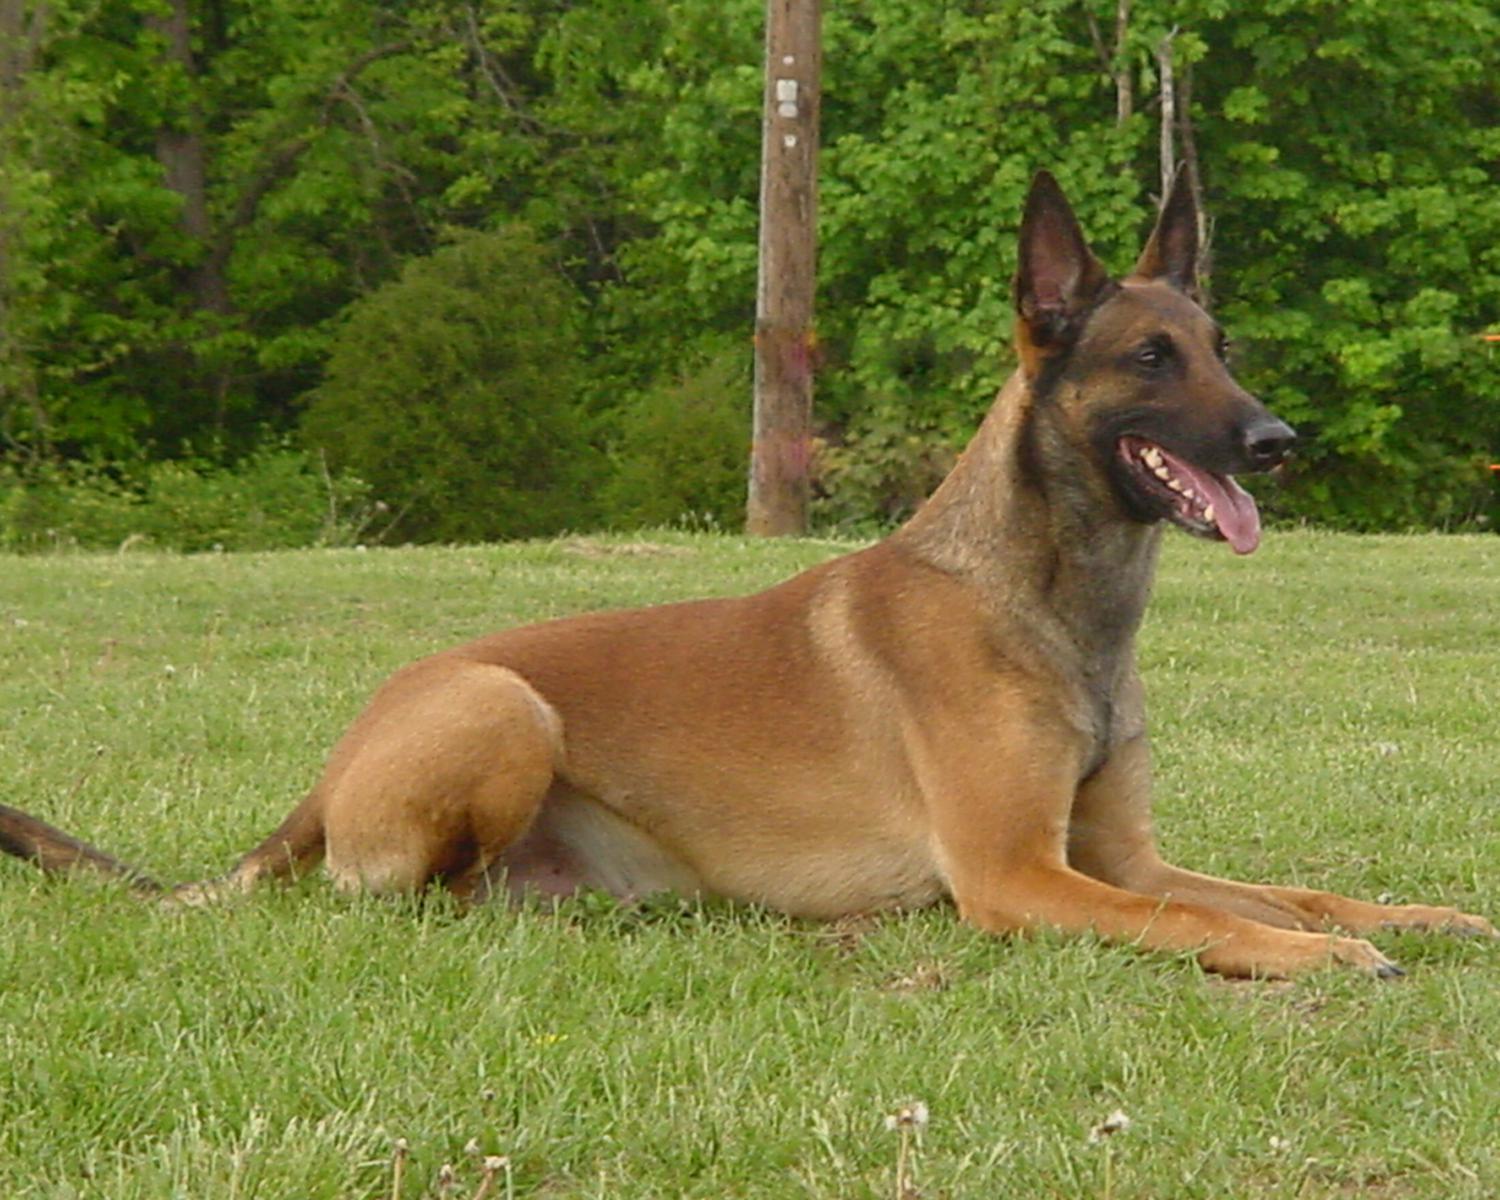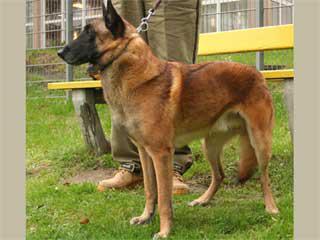The first image is the image on the left, the second image is the image on the right. Evaluate the accuracy of this statement regarding the images: "At least one dog is biting someone.". Is it true? Answer yes or no. No. 